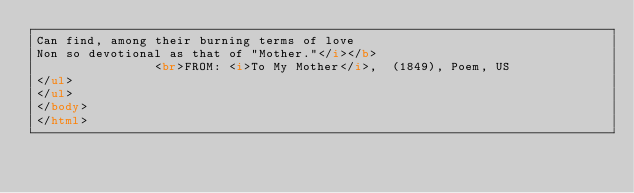Convert code to text. <code><loc_0><loc_0><loc_500><loc_500><_HTML_>Can find, among their burning terms of love
Non so devotional as that of "Mother."</i></b>
                <br>FROM: <i>To My Mother</i>,  (1849), Poem, US
</ul>
</ul>
</body>
</html>
</code> 